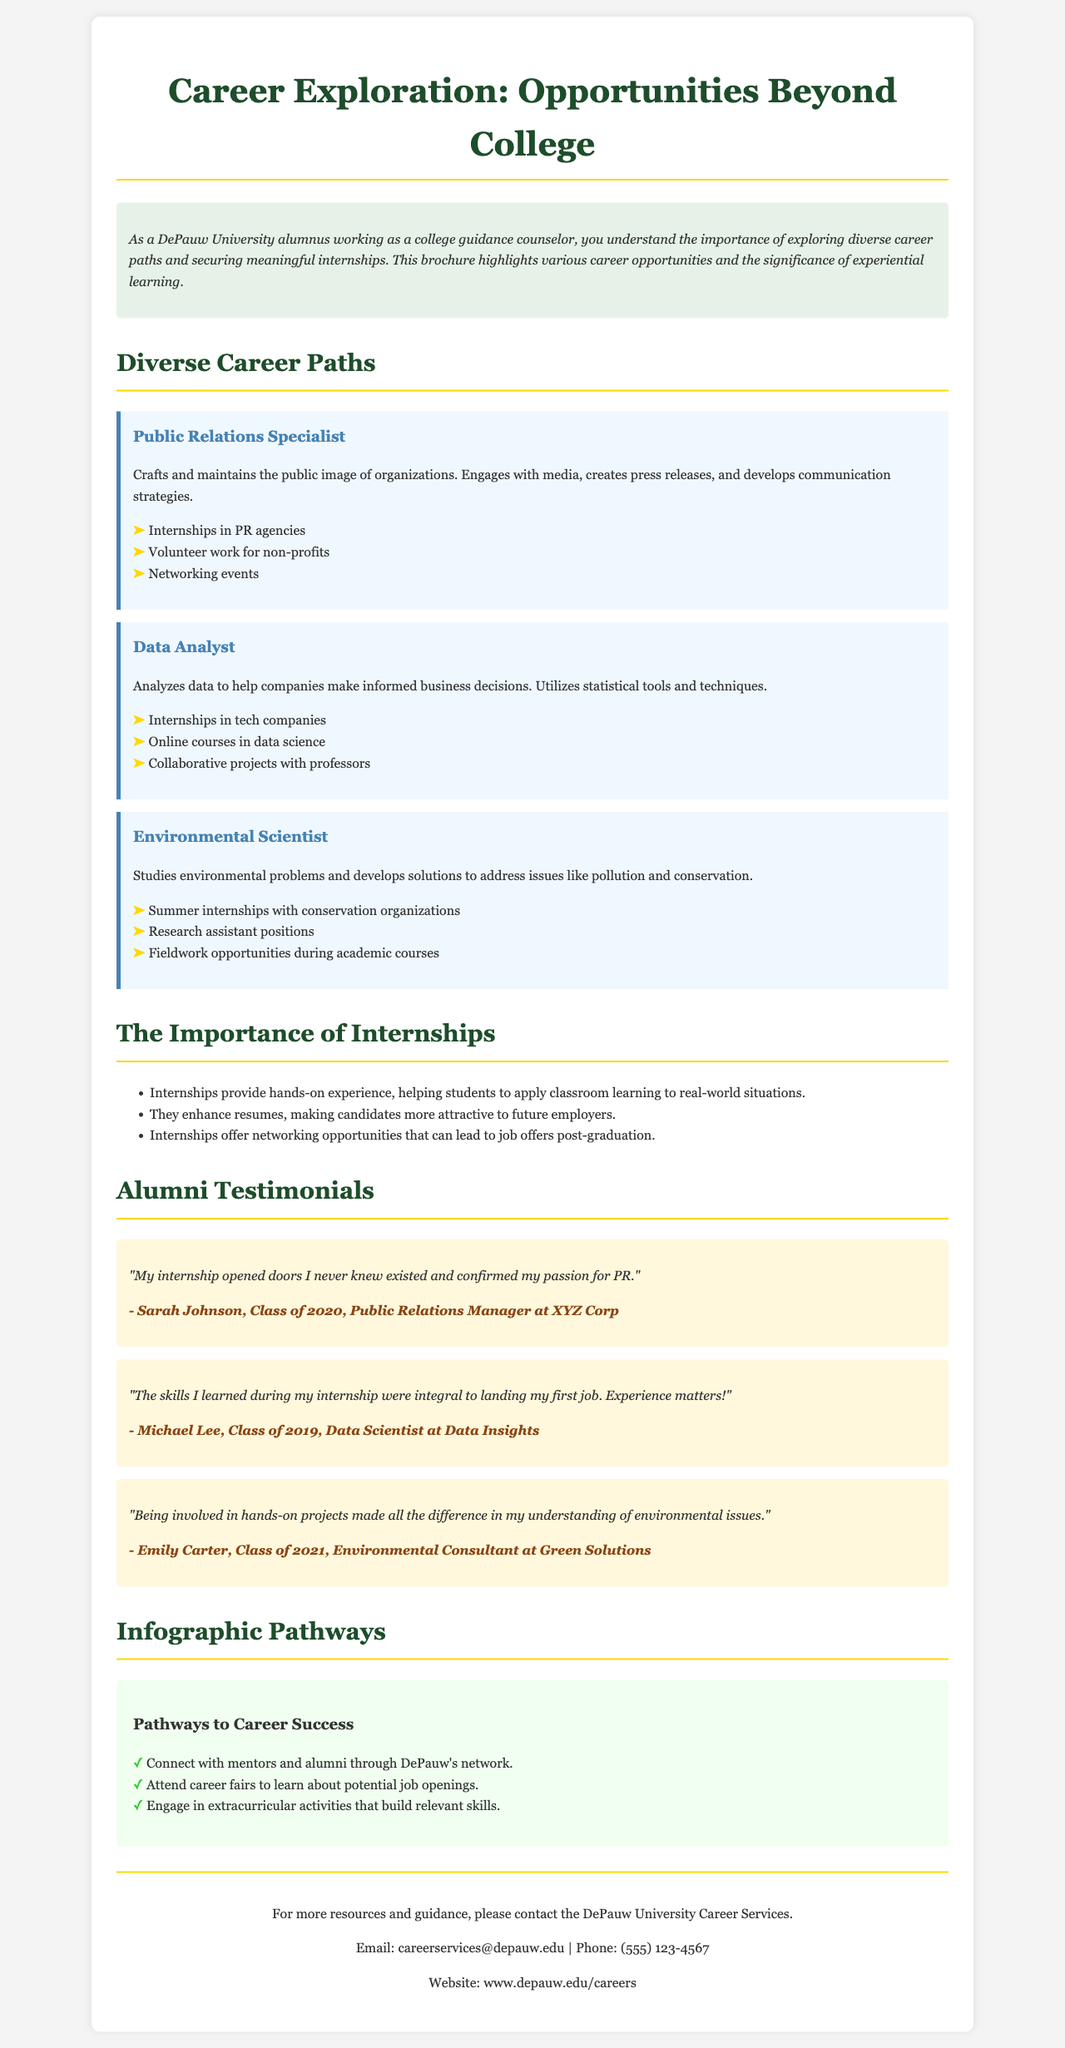What is the title of the brochure? The title is prominently displayed at the top of the document and indicates the main theme of the brochure.
Answer: Career Exploration: Opportunities Beyond College Who is the target audience for this brochure? The content indicates that it is aimed at college students and guidance counselors, particularly DePauw University alumni.
Answer: DePauw University alumni What position does Sarah Johnson hold? The testimonial provided in the brochure explicitly mentions her current job title.
Answer: Public Relations Manager What type of internships does a Data Analyst pursue? The section on diverse career paths lists relevant internship opportunities for a Data Analyst.
Answer: Internships in tech companies What is one key benefit of internships mentioned in the document? The brochure outlines multiple advantages of internships, focusing on their contribution to career readiness.
Answer: Enhance resumes How many testimonials are included in the brochure? The section under Alumni Testimonials counts the testimonials provided.
Answer: Three testimonials What color is used for the heading of the career paths? The document specifies the color used for the headings in the career paths section.
Answer: #4682B4 What is one pathway to career success mentioned in the infographic? The infographic section lists several strategies to achieve career success.
Answer: Connect with mentors and alumni through DePauw's network What did Emily Carter emphasize in her testimonial? Emily's testimonial highlights her experience with hands-on projects in her field.
Answer: Understanding of environmental issues 